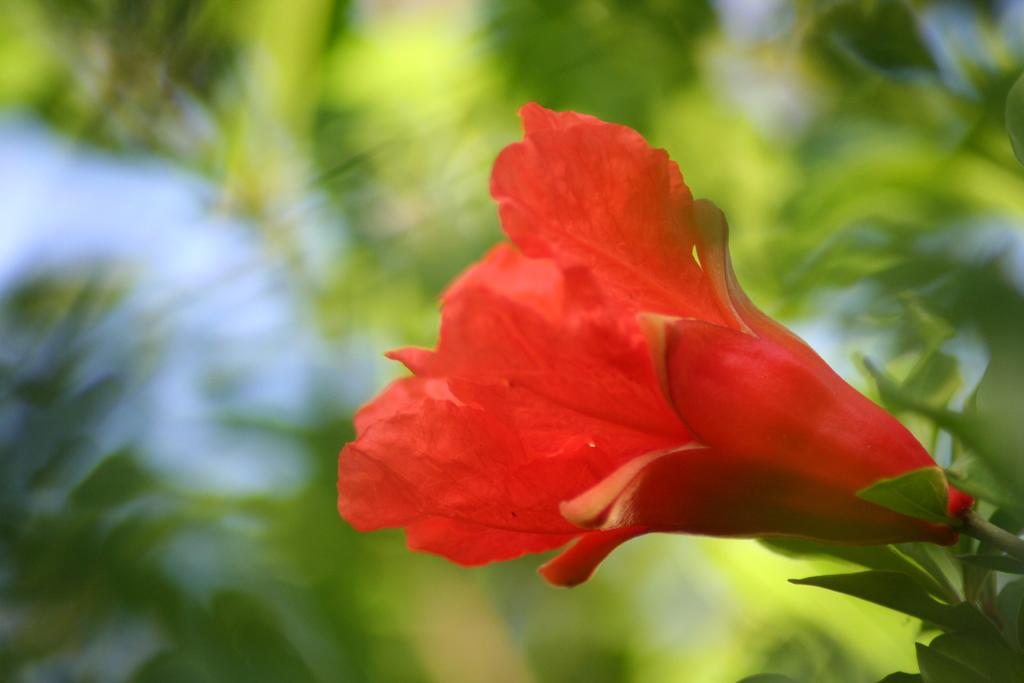What type of plant is visible on the right side of the image? There is a flower on the right side of the image. What color are the leaves visible in the background of the image? The leaves in the background are green. Can you describe any other objects present in the background of the image? Unfortunately, the provided facts do not give any information about other objects in the background. What type of jam is being used to fuel the engine in the image? There is no engine or jam present in the image, so this question cannot be answered. 